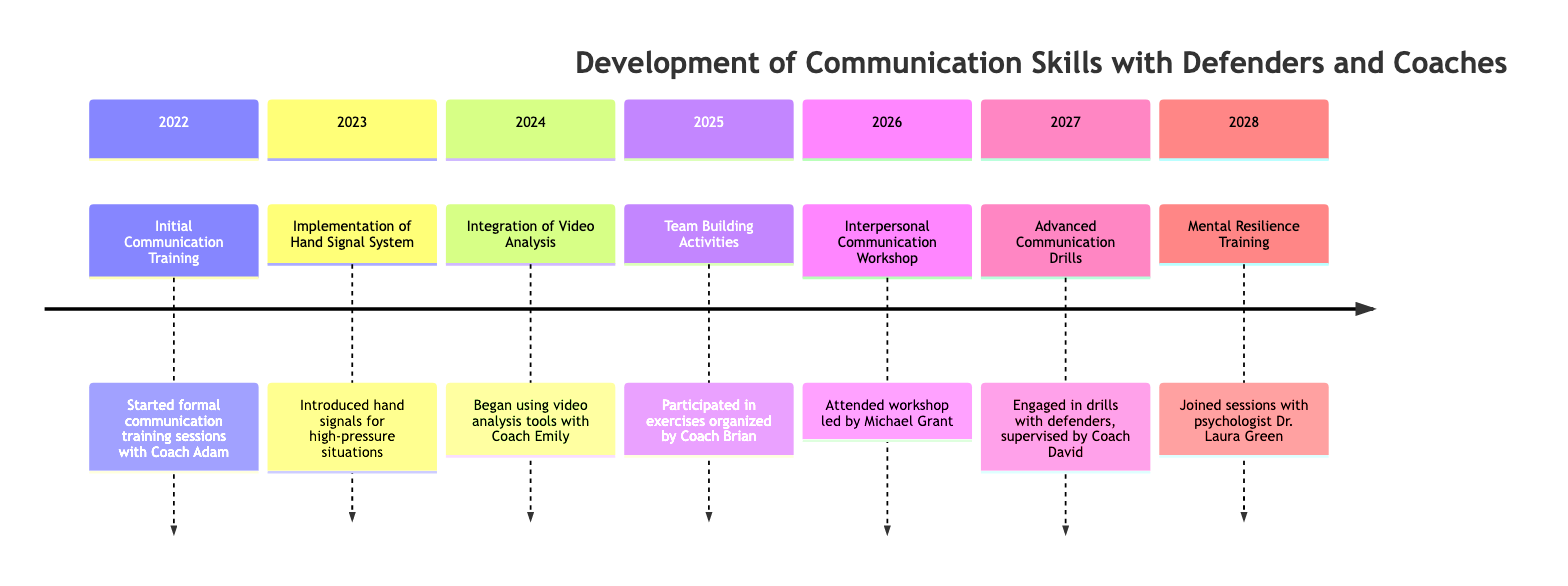What year did the Initial Communication Training take place? The diagram indicates that the event "Initial Communication Training" occurred in the year 2022, as it is the first event listed on the timeline.
Answer: 2022 How many events are listed in the timeline? By counting each distinct event shown in the timeline, we find there are a total of 7 events: Initial Communication Training, Implementation of Hand Signal System, Integration of Video Analysis, Team Building Activities, Interpersonal Communication Workshop, Advanced Communication Drills, and Mental Resilience Training.
Answer: 7 What was introduced in 2023 to help in high-pressure situations? The event from 2023 states "Implementation of Hand Signal System," which indicates that hand signals were introduced to facilitate communication under stress.
Answer: Hand Signal System Who led the Interpersonal Communication Workshop? The timeline specifies that the "Interpersonal Communication Workshop" was led by Michael Grant, identifying him as the expert speaker for this event.
Answer: Michael Grant What type of training did I participate in during 2026? According to the timeline, specifically the event in 2026, the training was an "Interpersonal Communication Workshop," indicating the focus on refining communication skills.
Answer: Interpersonal Communication Workshop Which coach organized the team-building activities in 2025? The description for the event in 2025 reveals that Coach Brian was responsible for organizing the team-building exercises, thus he is the designated coach for that year.
Answer: Coach Brian What tool was integrated for communication improvement in 2024? The timeline for 2024 mentions the "Integration of Video Analysis" as a tool used to enhance communication strategies, pointing to the importance of video in reviewing performance.
Answer: Video Analysis What training sessions did I join in 2028? The event for 2028 states "Mental Resilience Training" held with psychologist Dr. Laura Green, indicating that these sessions focused on building mental toughness and calmness.
Answer: Mental Resilience Training 